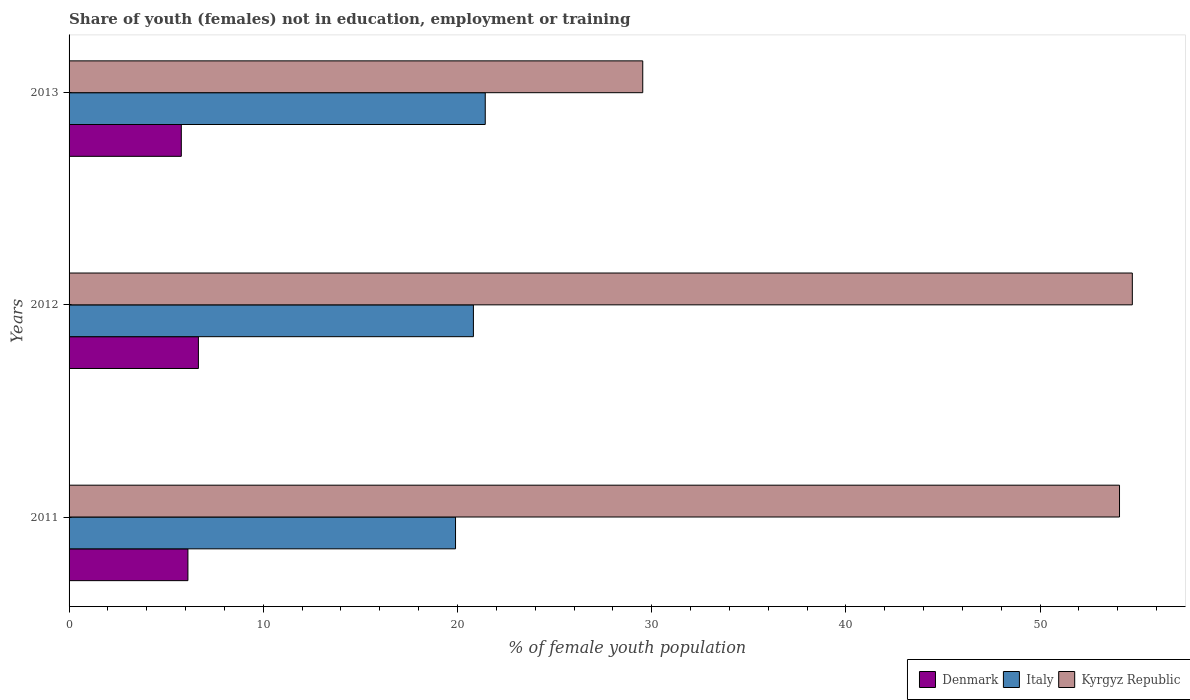How many groups of bars are there?
Give a very brief answer. 3. How many bars are there on the 3rd tick from the bottom?
Offer a terse response. 3. What is the percentage of unemployed female population in in Denmark in 2012?
Your response must be concise. 6.66. Across all years, what is the maximum percentage of unemployed female population in in Denmark?
Provide a succinct answer. 6.66. Across all years, what is the minimum percentage of unemployed female population in in Denmark?
Your answer should be compact. 5.78. In which year was the percentage of unemployed female population in in Denmark maximum?
Make the answer very short. 2012. What is the total percentage of unemployed female population in in Denmark in the graph?
Ensure brevity in your answer.  18.56. What is the difference between the percentage of unemployed female population in in Italy in 2011 and that in 2013?
Keep it short and to the point. -1.53. What is the difference between the percentage of unemployed female population in in Denmark in 2011 and the percentage of unemployed female population in in Italy in 2012?
Offer a very short reply. -14.7. What is the average percentage of unemployed female population in in Italy per year?
Keep it short and to the point. 20.72. In the year 2013, what is the difference between the percentage of unemployed female population in in Denmark and percentage of unemployed female population in in Italy?
Your answer should be very brief. -15.65. What is the ratio of the percentage of unemployed female population in in Italy in 2011 to that in 2013?
Ensure brevity in your answer.  0.93. Is the difference between the percentage of unemployed female population in in Denmark in 2012 and 2013 greater than the difference between the percentage of unemployed female population in in Italy in 2012 and 2013?
Your answer should be compact. Yes. What is the difference between the highest and the second highest percentage of unemployed female population in in Denmark?
Make the answer very short. 0.54. What is the difference between the highest and the lowest percentage of unemployed female population in in Italy?
Give a very brief answer. 1.53. What does the 2nd bar from the top in 2012 represents?
Your response must be concise. Italy. Is it the case that in every year, the sum of the percentage of unemployed female population in in Italy and percentage of unemployed female population in in Kyrgyz Republic is greater than the percentage of unemployed female population in in Denmark?
Ensure brevity in your answer.  Yes. How many bars are there?
Make the answer very short. 9. What is the difference between two consecutive major ticks on the X-axis?
Your answer should be very brief. 10. Are the values on the major ticks of X-axis written in scientific E-notation?
Provide a succinct answer. No. Does the graph contain any zero values?
Offer a very short reply. No. Where does the legend appear in the graph?
Provide a succinct answer. Bottom right. How many legend labels are there?
Offer a terse response. 3. What is the title of the graph?
Give a very brief answer. Share of youth (females) not in education, employment or training. Does "Fragile and conflict affected situations" appear as one of the legend labels in the graph?
Keep it short and to the point. No. What is the label or title of the X-axis?
Your response must be concise. % of female youth population. What is the % of female youth population of Denmark in 2011?
Keep it short and to the point. 6.12. What is the % of female youth population of Italy in 2011?
Ensure brevity in your answer.  19.9. What is the % of female youth population of Kyrgyz Republic in 2011?
Give a very brief answer. 54.09. What is the % of female youth population in Denmark in 2012?
Provide a succinct answer. 6.66. What is the % of female youth population of Italy in 2012?
Offer a very short reply. 20.82. What is the % of female youth population of Kyrgyz Republic in 2012?
Make the answer very short. 54.75. What is the % of female youth population in Denmark in 2013?
Keep it short and to the point. 5.78. What is the % of female youth population in Italy in 2013?
Your answer should be compact. 21.43. What is the % of female youth population in Kyrgyz Republic in 2013?
Make the answer very short. 29.54. Across all years, what is the maximum % of female youth population in Denmark?
Your answer should be very brief. 6.66. Across all years, what is the maximum % of female youth population in Italy?
Ensure brevity in your answer.  21.43. Across all years, what is the maximum % of female youth population in Kyrgyz Republic?
Ensure brevity in your answer.  54.75. Across all years, what is the minimum % of female youth population in Denmark?
Offer a very short reply. 5.78. Across all years, what is the minimum % of female youth population of Italy?
Keep it short and to the point. 19.9. Across all years, what is the minimum % of female youth population in Kyrgyz Republic?
Your response must be concise. 29.54. What is the total % of female youth population of Denmark in the graph?
Offer a terse response. 18.56. What is the total % of female youth population in Italy in the graph?
Provide a short and direct response. 62.15. What is the total % of female youth population in Kyrgyz Republic in the graph?
Offer a terse response. 138.38. What is the difference between the % of female youth population in Denmark in 2011 and that in 2012?
Your response must be concise. -0.54. What is the difference between the % of female youth population of Italy in 2011 and that in 2012?
Offer a terse response. -0.92. What is the difference between the % of female youth population of Kyrgyz Republic in 2011 and that in 2012?
Keep it short and to the point. -0.66. What is the difference between the % of female youth population of Denmark in 2011 and that in 2013?
Ensure brevity in your answer.  0.34. What is the difference between the % of female youth population in Italy in 2011 and that in 2013?
Your answer should be very brief. -1.53. What is the difference between the % of female youth population of Kyrgyz Republic in 2011 and that in 2013?
Provide a short and direct response. 24.55. What is the difference between the % of female youth population of Italy in 2012 and that in 2013?
Your response must be concise. -0.61. What is the difference between the % of female youth population of Kyrgyz Republic in 2012 and that in 2013?
Ensure brevity in your answer.  25.21. What is the difference between the % of female youth population of Denmark in 2011 and the % of female youth population of Italy in 2012?
Your answer should be very brief. -14.7. What is the difference between the % of female youth population in Denmark in 2011 and the % of female youth population in Kyrgyz Republic in 2012?
Your answer should be compact. -48.63. What is the difference between the % of female youth population in Italy in 2011 and the % of female youth population in Kyrgyz Republic in 2012?
Provide a short and direct response. -34.85. What is the difference between the % of female youth population in Denmark in 2011 and the % of female youth population in Italy in 2013?
Your response must be concise. -15.31. What is the difference between the % of female youth population of Denmark in 2011 and the % of female youth population of Kyrgyz Republic in 2013?
Provide a short and direct response. -23.42. What is the difference between the % of female youth population of Italy in 2011 and the % of female youth population of Kyrgyz Republic in 2013?
Provide a succinct answer. -9.64. What is the difference between the % of female youth population in Denmark in 2012 and the % of female youth population in Italy in 2013?
Your response must be concise. -14.77. What is the difference between the % of female youth population in Denmark in 2012 and the % of female youth population in Kyrgyz Republic in 2013?
Provide a succinct answer. -22.88. What is the difference between the % of female youth population in Italy in 2012 and the % of female youth population in Kyrgyz Republic in 2013?
Your answer should be very brief. -8.72. What is the average % of female youth population of Denmark per year?
Offer a very short reply. 6.19. What is the average % of female youth population in Italy per year?
Make the answer very short. 20.72. What is the average % of female youth population in Kyrgyz Republic per year?
Offer a terse response. 46.13. In the year 2011, what is the difference between the % of female youth population in Denmark and % of female youth population in Italy?
Ensure brevity in your answer.  -13.78. In the year 2011, what is the difference between the % of female youth population of Denmark and % of female youth population of Kyrgyz Republic?
Keep it short and to the point. -47.97. In the year 2011, what is the difference between the % of female youth population of Italy and % of female youth population of Kyrgyz Republic?
Keep it short and to the point. -34.19. In the year 2012, what is the difference between the % of female youth population in Denmark and % of female youth population in Italy?
Offer a very short reply. -14.16. In the year 2012, what is the difference between the % of female youth population of Denmark and % of female youth population of Kyrgyz Republic?
Offer a very short reply. -48.09. In the year 2012, what is the difference between the % of female youth population in Italy and % of female youth population in Kyrgyz Republic?
Offer a very short reply. -33.93. In the year 2013, what is the difference between the % of female youth population in Denmark and % of female youth population in Italy?
Provide a short and direct response. -15.65. In the year 2013, what is the difference between the % of female youth population in Denmark and % of female youth population in Kyrgyz Republic?
Provide a succinct answer. -23.76. In the year 2013, what is the difference between the % of female youth population of Italy and % of female youth population of Kyrgyz Republic?
Ensure brevity in your answer.  -8.11. What is the ratio of the % of female youth population of Denmark in 2011 to that in 2012?
Provide a short and direct response. 0.92. What is the ratio of the % of female youth population in Italy in 2011 to that in 2012?
Keep it short and to the point. 0.96. What is the ratio of the % of female youth population of Kyrgyz Republic in 2011 to that in 2012?
Keep it short and to the point. 0.99. What is the ratio of the % of female youth population of Denmark in 2011 to that in 2013?
Keep it short and to the point. 1.06. What is the ratio of the % of female youth population of Italy in 2011 to that in 2013?
Make the answer very short. 0.93. What is the ratio of the % of female youth population in Kyrgyz Republic in 2011 to that in 2013?
Ensure brevity in your answer.  1.83. What is the ratio of the % of female youth population in Denmark in 2012 to that in 2013?
Your answer should be very brief. 1.15. What is the ratio of the % of female youth population in Italy in 2012 to that in 2013?
Offer a terse response. 0.97. What is the ratio of the % of female youth population in Kyrgyz Republic in 2012 to that in 2013?
Make the answer very short. 1.85. What is the difference between the highest and the second highest % of female youth population in Denmark?
Make the answer very short. 0.54. What is the difference between the highest and the second highest % of female youth population of Italy?
Make the answer very short. 0.61. What is the difference between the highest and the second highest % of female youth population of Kyrgyz Republic?
Ensure brevity in your answer.  0.66. What is the difference between the highest and the lowest % of female youth population of Denmark?
Your answer should be very brief. 0.88. What is the difference between the highest and the lowest % of female youth population of Italy?
Your answer should be very brief. 1.53. What is the difference between the highest and the lowest % of female youth population of Kyrgyz Republic?
Your answer should be very brief. 25.21. 